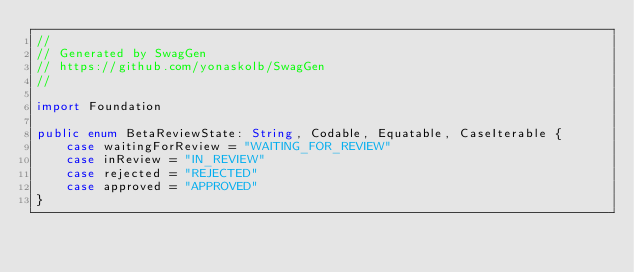Convert code to text. <code><loc_0><loc_0><loc_500><loc_500><_Swift_>//
// Generated by SwagGen
// https://github.com/yonaskolb/SwagGen
//

import Foundation

public enum BetaReviewState: String, Codable, Equatable, CaseIterable {
    case waitingForReview = "WAITING_FOR_REVIEW"
    case inReview = "IN_REVIEW"
    case rejected = "REJECTED"
    case approved = "APPROVED"
}
</code> 